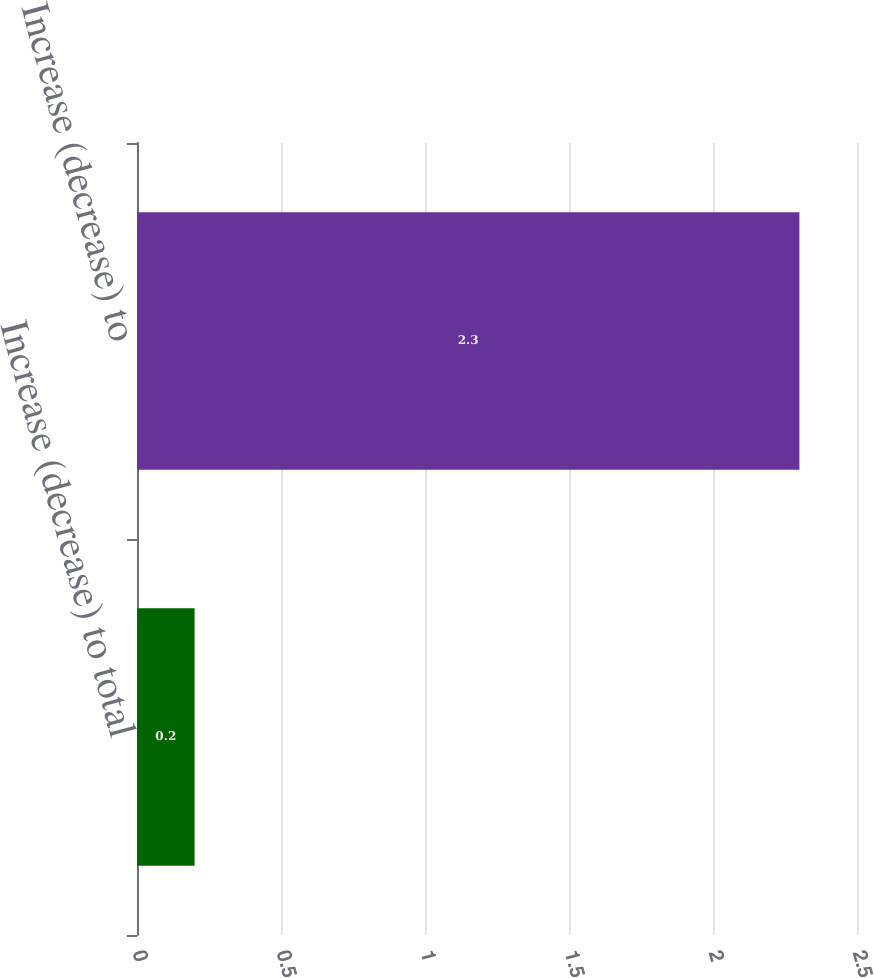Convert chart to OTSL. <chart><loc_0><loc_0><loc_500><loc_500><bar_chart><fcel>Increase (decrease) to total<fcel>Increase (decrease) to<nl><fcel>0.2<fcel>2.3<nl></chart> 